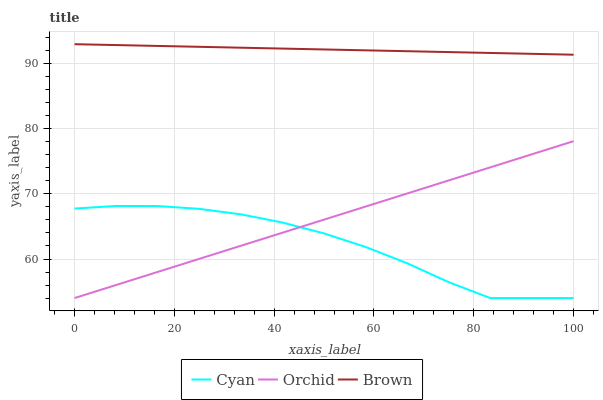Does Cyan have the minimum area under the curve?
Answer yes or no. Yes. Does Brown have the maximum area under the curve?
Answer yes or no. Yes. Does Orchid have the minimum area under the curve?
Answer yes or no. No. Does Orchid have the maximum area under the curve?
Answer yes or no. No. Is Brown the smoothest?
Answer yes or no. Yes. Is Cyan the roughest?
Answer yes or no. Yes. Is Orchid the smoothest?
Answer yes or no. No. Is Orchid the roughest?
Answer yes or no. No. Does Cyan have the lowest value?
Answer yes or no. Yes. Does Brown have the lowest value?
Answer yes or no. No. Does Brown have the highest value?
Answer yes or no. Yes. Does Orchid have the highest value?
Answer yes or no. No. Is Cyan less than Brown?
Answer yes or no. Yes. Is Brown greater than Orchid?
Answer yes or no. Yes. Does Cyan intersect Orchid?
Answer yes or no. Yes. Is Cyan less than Orchid?
Answer yes or no. No. Is Cyan greater than Orchid?
Answer yes or no. No. Does Cyan intersect Brown?
Answer yes or no. No. 